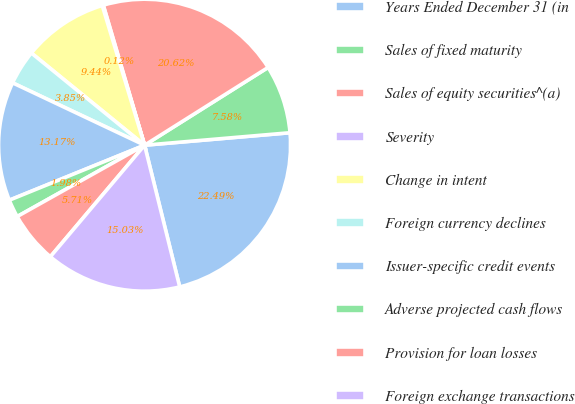<chart> <loc_0><loc_0><loc_500><loc_500><pie_chart><fcel>Years Ended December 31 (in<fcel>Sales of fixed maturity<fcel>Sales of equity securities^(a)<fcel>Severity<fcel>Change in intent<fcel>Foreign currency declines<fcel>Issuer-specific credit events<fcel>Adverse projected cash flows<fcel>Provision for loan losses<fcel>Foreign exchange transactions<nl><fcel>22.49%<fcel>7.58%<fcel>20.62%<fcel>0.12%<fcel>9.44%<fcel>3.85%<fcel>13.17%<fcel>1.98%<fcel>5.71%<fcel>15.03%<nl></chart> 